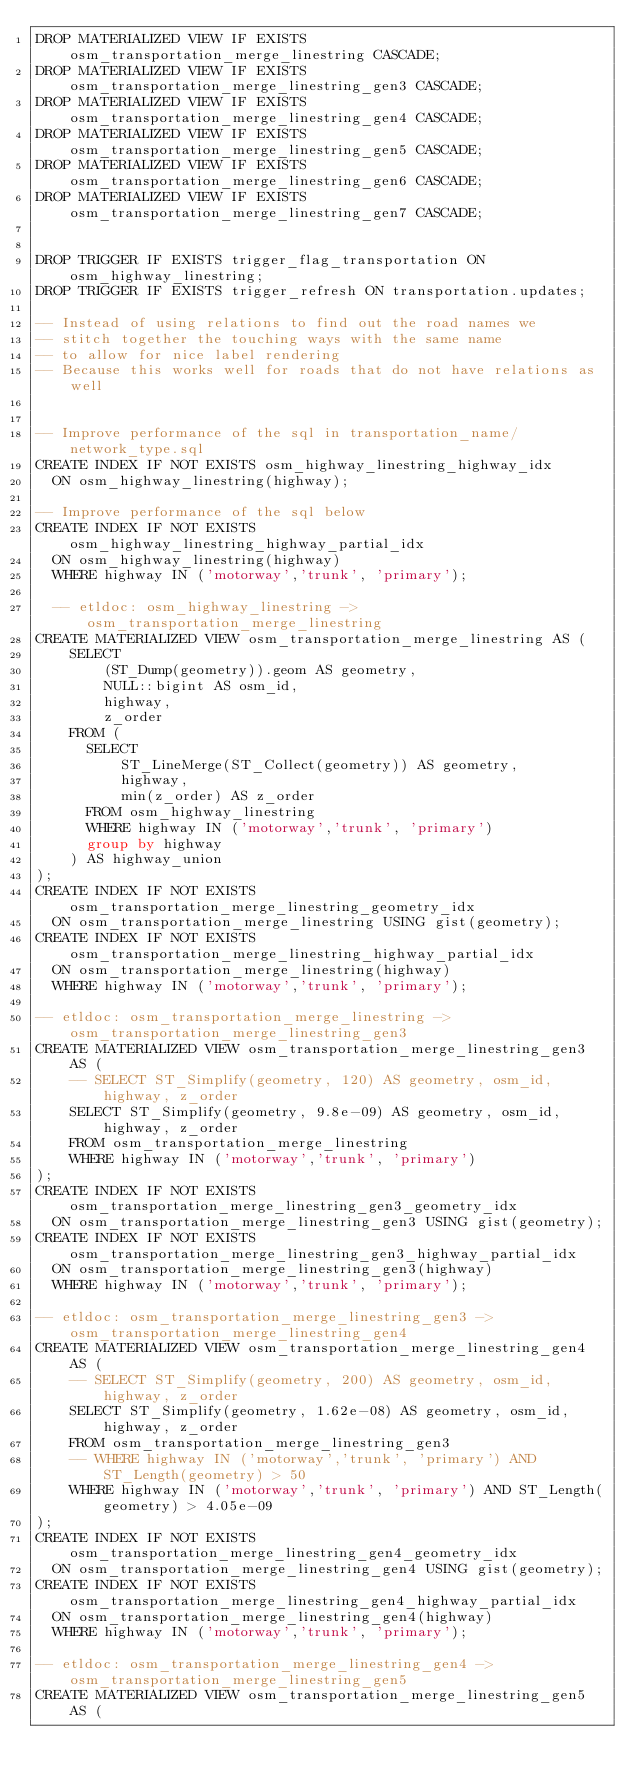Convert code to text. <code><loc_0><loc_0><loc_500><loc_500><_SQL_>DROP MATERIALIZED VIEW IF EXISTS osm_transportation_merge_linestring CASCADE;
DROP MATERIALIZED VIEW IF EXISTS osm_transportation_merge_linestring_gen3 CASCADE;
DROP MATERIALIZED VIEW IF EXISTS osm_transportation_merge_linestring_gen4 CASCADE;
DROP MATERIALIZED VIEW IF EXISTS osm_transportation_merge_linestring_gen5 CASCADE;
DROP MATERIALIZED VIEW IF EXISTS osm_transportation_merge_linestring_gen6 CASCADE;
DROP MATERIALIZED VIEW IF EXISTS osm_transportation_merge_linestring_gen7 CASCADE;


DROP TRIGGER IF EXISTS trigger_flag_transportation ON osm_highway_linestring;
DROP TRIGGER IF EXISTS trigger_refresh ON transportation.updates;

-- Instead of using relations to find out the road names we
-- stitch together the touching ways with the same name
-- to allow for nice label rendering
-- Because this works well for roads that do not have relations as well


-- Improve performance of the sql in transportation_name/network_type.sql
CREATE INDEX IF NOT EXISTS osm_highway_linestring_highway_idx
  ON osm_highway_linestring(highway);

-- Improve performance of the sql below
CREATE INDEX IF NOT EXISTS osm_highway_linestring_highway_partial_idx
  ON osm_highway_linestring(highway)
  WHERE highway IN ('motorway','trunk', 'primary');

  -- etldoc: osm_highway_linestring ->  osm_transportation_merge_linestring
CREATE MATERIALIZED VIEW osm_transportation_merge_linestring AS (
    SELECT
        (ST_Dump(geometry)).geom AS geometry,
        NULL::bigint AS osm_id,
        highway,
        z_order
    FROM (
      SELECT
          ST_LineMerge(ST_Collect(geometry)) AS geometry,
          highway,
          min(z_order) AS z_order
      FROM osm_highway_linestring
      WHERE highway IN ('motorway','trunk', 'primary')
      group by highway
    ) AS highway_union
);
CREATE INDEX IF NOT EXISTS osm_transportation_merge_linestring_geometry_idx
  ON osm_transportation_merge_linestring USING gist(geometry);
CREATE INDEX IF NOT EXISTS osm_transportation_merge_linestring_highway_partial_idx
  ON osm_transportation_merge_linestring(highway)
  WHERE highway IN ('motorway','trunk', 'primary');

-- etldoc: osm_transportation_merge_linestring -> osm_transportation_merge_linestring_gen3
CREATE MATERIALIZED VIEW osm_transportation_merge_linestring_gen3 AS (
    -- SELECT ST_Simplify(geometry, 120) AS geometry, osm_id, highway, z_order
    SELECT ST_Simplify(geometry, 9.8e-09) AS geometry, osm_id, highway, z_order
    FROM osm_transportation_merge_linestring
    WHERE highway IN ('motorway','trunk', 'primary')
);
CREATE INDEX IF NOT EXISTS osm_transportation_merge_linestring_gen3_geometry_idx
  ON osm_transportation_merge_linestring_gen3 USING gist(geometry);
CREATE INDEX IF NOT EXISTS osm_transportation_merge_linestring_gen3_highway_partial_idx
  ON osm_transportation_merge_linestring_gen3(highway)
  WHERE highway IN ('motorway','trunk', 'primary');

-- etldoc: osm_transportation_merge_linestring_gen3 -> osm_transportation_merge_linestring_gen4
CREATE MATERIALIZED VIEW osm_transportation_merge_linestring_gen4 AS (
    -- SELECT ST_Simplify(geometry, 200) AS geometry, osm_id, highway, z_order
    SELECT ST_Simplify(geometry, 1.62e-08) AS geometry, osm_id, highway, z_order
    FROM osm_transportation_merge_linestring_gen3
    -- WHERE highway IN ('motorway','trunk', 'primary') AND ST_Length(geometry) > 50
    WHERE highway IN ('motorway','trunk', 'primary') AND ST_Length(geometry) > 4.05e-09
);
CREATE INDEX IF NOT EXISTS osm_transportation_merge_linestring_gen4_geometry_idx
  ON osm_transportation_merge_linestring_gen4 USING gist(geometry);
CREATE INDEX IF NOT EXISTS osm_transportation_merge_linestring_gen4_highway_partial_idx
  ON osm_transportation_merge_linestring_gen4(highway)
  WHERE highway IN ('motorway','trunk', 'primary');

-- etldoc: osm_transportation_merge_linestring_gen4 -> osm_transportation_merge_linestring_gen5
CREATE MATERIALIZED VIEW osm_transportation_merge_linestring_gen5 AS (</code> 